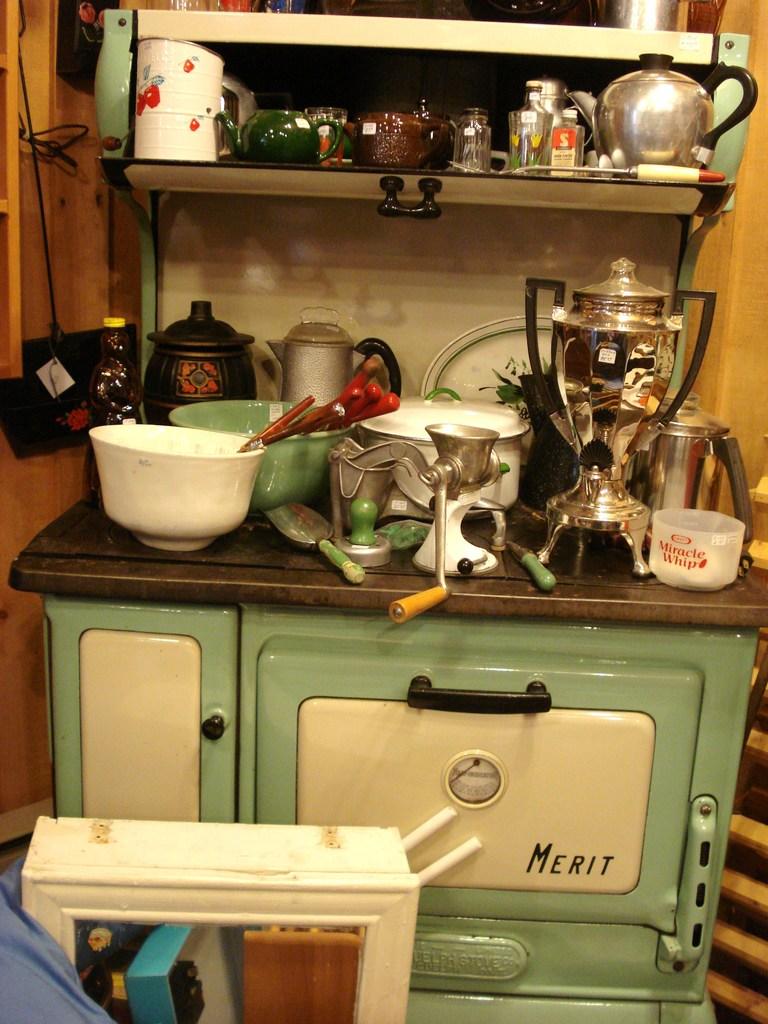What make is the cooker?
Keep it short and to the point. Merit. Do they have miracle whip?
Offer a very short reply. Yes. 